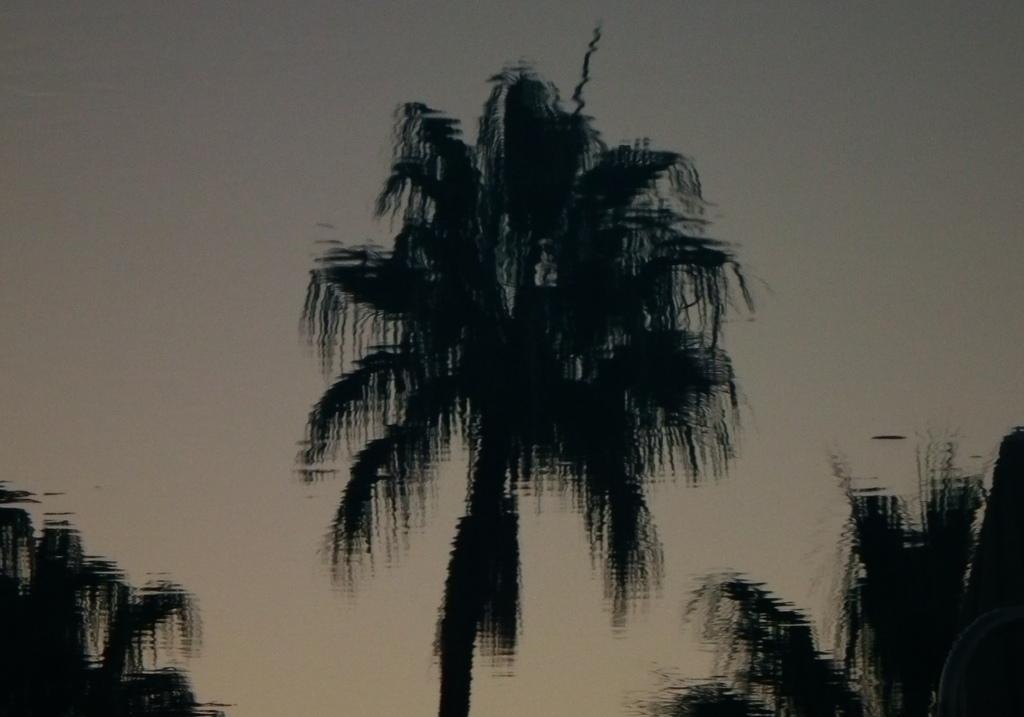Could you give a brief overview of what you see in this image? In this picture I can observe blur image of trees. In the background there is sky. 